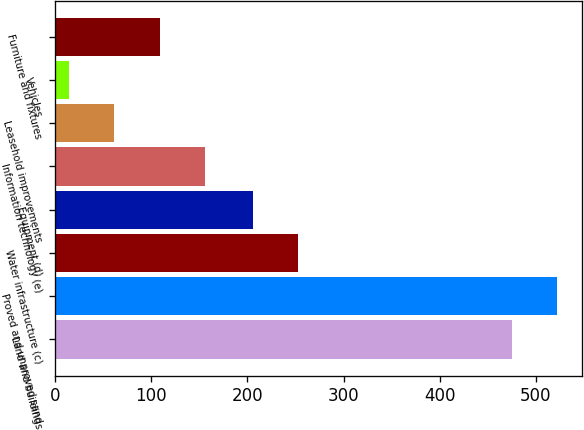Convert chart. <chart><loc_0><loc_0><loc_500><loc_500><bar_chart><fcel>Land and buildings<fcel>Proved and unproved sand<fcel>Water infrastructure (c)<fcel>Equipment (d)<fcel>Information technology (e)<fcel>Leasehold improvements<fcel>Vehicles<fcel>Furniture and fixtures<nl><fcel>475<fcel>521.9<fcel>252.9<fcel>206<fcel>155.7<fcel>61.9<fcel>15<fcel>108.8<nl></chart> 